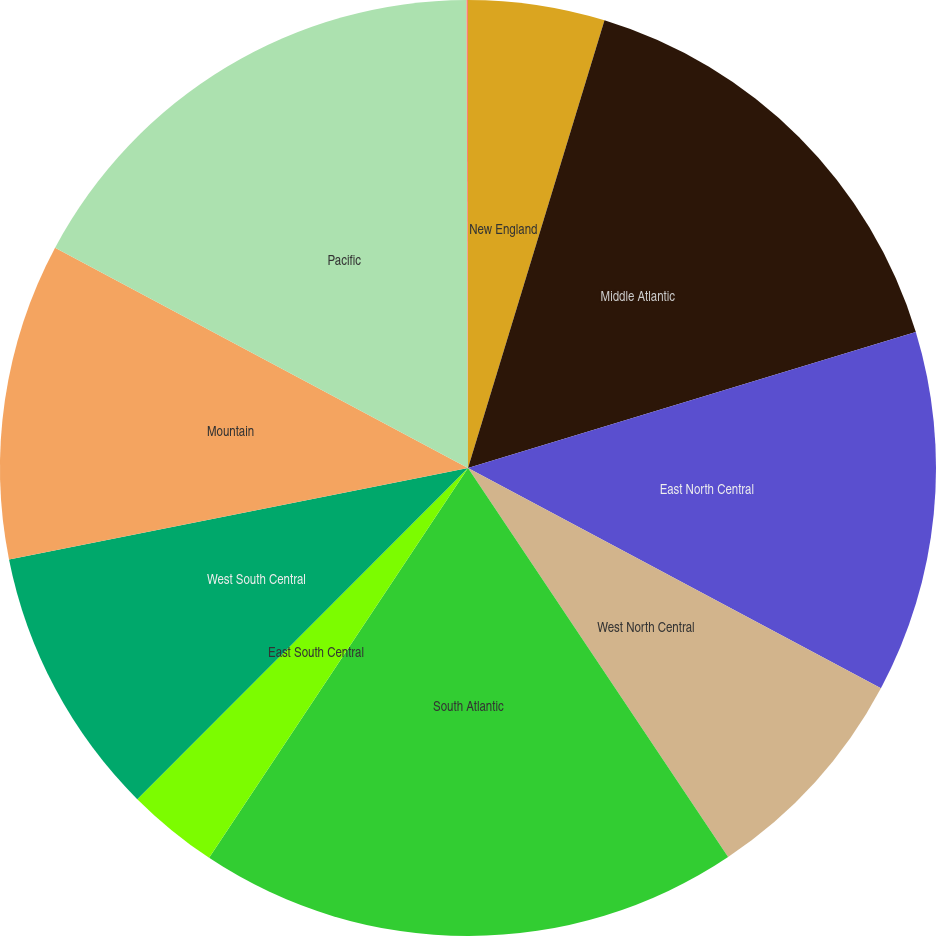Convert chart to OTSL. <chart><loc_0><loc_0><loc_500><loc_500><pie_chart><fcel>New England<fcel>Middle Atlantic<fcel>East North Central<fcel>West North Central<fcel>South Atlantic<fcel>East South Central<fcel>West South Central<fcel>Mountain<fcel>Pacific<fcel>Valuation allowance<nl><fcel>4.71%<fcel>15.6%<fcel>12.49%<fcel>7.82%<fcel>18.71%<fcel>3.16%<fcel>9.38%<fcel>10.93%<fcel>17.15%<fcel>0.05%<nl></chart> 